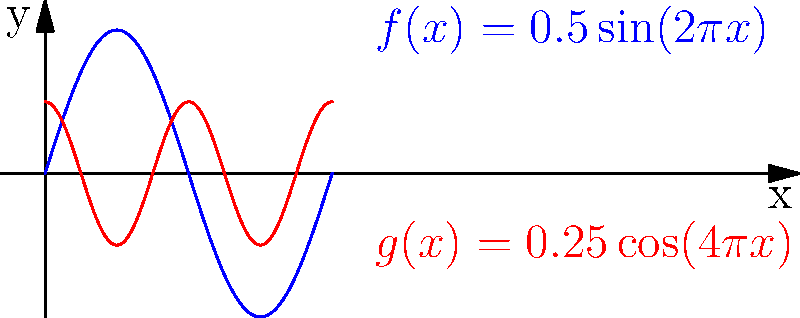Analyze the two curves shown in the image, which represent mathematical models of calligraphic strokes. How many times do these curves intersect each other in the interval $[0,1]$? To find the number of intersections, we need to solve the equation:

$$f(x) = g(x)$$

Substituting the given functions:

$$0.5\sin(2\pi x) = 0.25\cos(4\pi x)$$

This equation is challenging to solve analytically, so we'll approach it graphically:

1. Observe that $f(x)$ (blue curve) completes one full cycle in $[0,1]$.
2. $g(x)$ (red curve) completes two full cycles in the same interval.
3. The curves start at different points: $f(0) = 0$, while $g(0) = 0.25$.
4. As $x$ increases, the blue curve rises while the red curve falls, creating the first intersection.
5. This pattern repeats, creating intersections each time the blue curve rises and falls.
6. Counting carefully, we can see that the curves intersect 4 times in the interval $[0,1]$.

Each intersection represents a point where the calligraphic strokes modeled by these functions would cross or touch, creating a unique visual effect in the hypothetical handwriting or calligraphy.
Answer: 4 intersections 